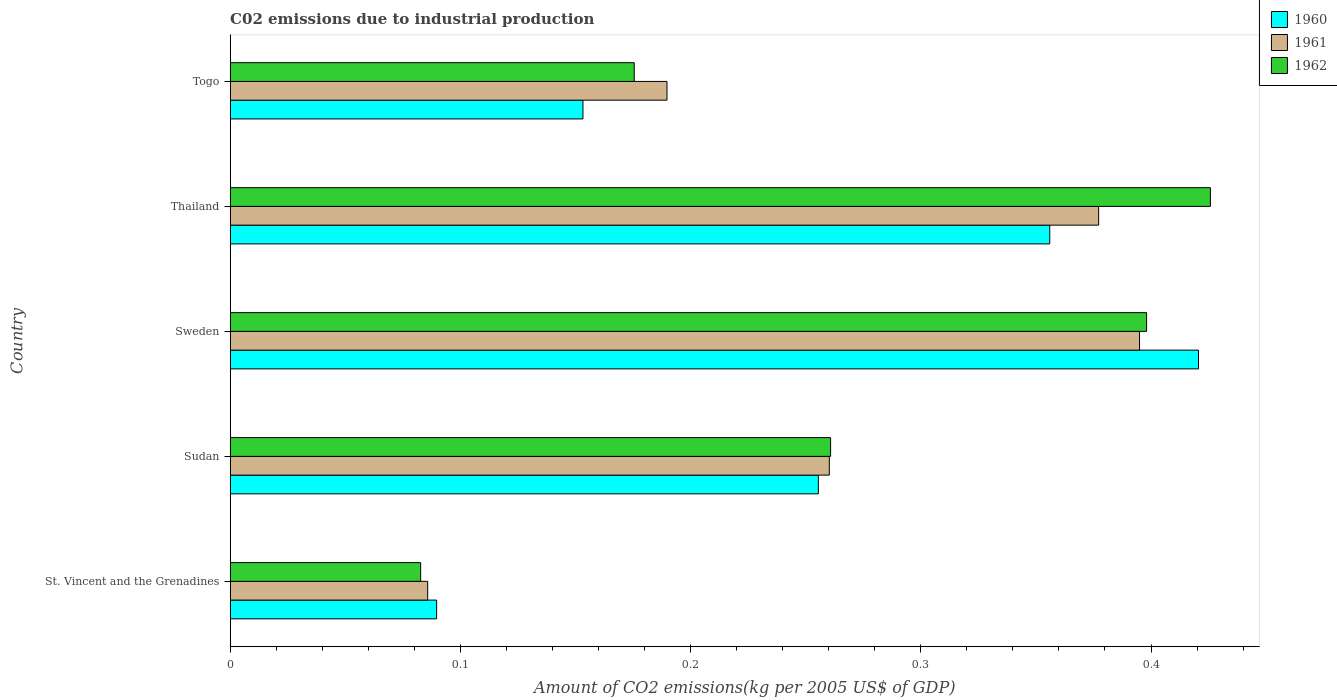Are the number of bars per tick equal to the number of legend labels?
Offer a very short reply. Yes. Are the number of bars on each tick of the Y-axis equal?
Give a very brief answer. Yes. How many bars are there on the 4th tick from the bottom?
Keep it short and to the point. 3. What is the label of the 4th group of bars from the top?
Offer a terse response. Sudan. What is the amount of CO2 emitted due to industrial production in 1961 in Sweden?
Your answer should be compact. 0.4. Across all countries, what is the maximum amount of CO2 emitted due to industrial production in 1962?
Your answer should be compact. 0.43. Across all countries, what is the minimum amount of CO2 emitted due to industrial production in 1962?
Your answer should be very brief. 0.08. In which country was the amount of CO2 emitted due to industrial production in 1961 maximum?
Keep it short and to the point. Sweden. In which country was the amount of CO2 emitted due to industrial production in 1962 minimum?
Provide a short and direct response. St. Vincent and the Grenadines. What is the total amount of CO2 emitted due to industrial production in 1962 in the graph?
Keep it short and to the point. 1.34. What is the difference between the amount of CO2 emitted due to industrial production in 1961 in Sweden and that in Togo?
Give a very brief answer. 0.21. What is the difference between the amount of CO2 emitted due to industrial production in 1961 in Togo and the amount of CO2 emitted due to industrial production in 1962 in Sweden?
Your response must be concise. -0.21. What is the average amount of CO2 emitted due to industrial production in 1960 per country?
Provide a succinct answer. 0.26. What is the difference between the amount of CO2 emitted due to industrial production in 1961 and amount of CO2 emitted due to industrial production in 1962 in Thailand?
Give a very brief answer. -0.05. What is the ratio of the amount of CO2 emitted due to industrial production in 1960 in St. Vincent and the Grenadines to that in Togo?
Your answer should be compact. 0.59. Is the difference between the amount of CO2 emitted due to industrial production in 1961 in St. Vincent and the Grenadines and Sudan greater than the difference between the amount of CO2 emitted due to industrial production in 1962 in St. Vincent and the Grenadines and Sudan?
Give a very brief answer. Yes. What is the difference between the highest and the second highest amount of CO2 emitted due to industrial production in 1961?
Your answer should be compact. 0.02. What is the difference between the highest and the lowest amount of CO2 emitted due to industrial production in 1960?
Give a very brief answer. 0.33. In how many countries, is the amount of CO2 emitted due to industrial production in 1960 greater than the average amount of CO2 emitted due to industrial production in 1960 taken over all countries?
Make the answer very short. 3. What does the 2nd bar from the bottom in Thailand represents?
Provide a succinct answer. 1961. Is it the case that in every country, the sum of the amount of CO2 emitted due to industrial production in 1960 and amount of CO2 emitted due to industrial production in 1961 is greater than the amount of CO2 emitted due to industrial production in 1962?
Your answer should be very brief. Yes. Are all the bars in the graph horizontal?
Keep it short and to the point. Yes. How many countries are there in the graph?
Keep it short and to the point. 5. Does the graph contain any zero values?
Ensure brevity in your answer.  No. How many legend labels are there?
Ensure brevity in your answer.  3. How are the legend labels stacked?
Give a very brief answer. Vertical. What is the title of the graph?
Keep it short and to the point. C02 emissions due to industrial production. What is the label or title of the X-axis?
Offer a terse response. Amount of CO2 emissions(kg per 2005 US$ of GDP). What is the Amount of CO2 emissions(kg per 2005 US$ of GDP) of 1960 in St. Vincent and the Grenadines?
Give a very brief answer. 0.09. What is the Amount of CO2 emissions(kg per 2005 US$ of GDP) in 1961 in St. Vincent and the Grenadines?
Provide a short and direct response. 0.09. What is the Amount of CO2 emissions(kg per 2005 US$ of GDP) in 1962 in St. Vincent and the Grenadines?
Your response must be concise. 0.08. What is the Amount of CO2 emissions(kg per 2005 US$ of GDP) in 1960 in Sudan?
Offer a terse response. 0.26. What is the Amount of CO2 emissions(kg per 2005 US$ of GDP) in 1961 in Sudan?
Offer a very short reply. 0.26. What is the Amount of CO2 emissions(kg per 2005 US$ of GDP) in 1962 in Sudan?
Your response must be concise. 0.26. What is the Amount of CO2 emissions(kg per 2005 US$ of GDP) of 1960 in Sweden?
Your response must be concise. 0.42. What is the Amount of CO2 emissions(kg per 2005 US$ of GDP) of 1961 in Sweden?
Your answer should be compact. 0.4. What is the Amount of CO2 emissions(kg per 2005 US$ of GDP) of 1962 in Sweden?
Your answer should be compact. 0.4. What is the Amount of CO2 emissions(kg per 2005 US$ of GDP) of 1960 in Thailand?
Make the answer very short. 0.36. What is the Amount of CO2 emissions(kg per 2005 US$ of GDP) of 1961 in Thailand?
Your answer should be compact. 0.38. What is the Amount of CO2 emissions(kg per 2005 US$ of GDP) of 1962 in Thailand?
Provide a short and direct response. 0.43. What is the Amount of CO2 emissions(kg per 2005 US$ of GDP) in 1960 in Togo?
Ensure brevity in your answer.  0.15. What is the Amount of CO2 emissions(kg per 2005 US$ of GDP) of 1961 in Togo?
Offer a very short reply. 0.19. What is the Amount of CO2 emissions(kg per 2005 US$ of GDP) in 1962 in Togo?
Make the answer very short. 0.18. Across all countries, what is the maximum Amount of CO2 emissions(kg per 2005 US$ of GDP) in 1960?
Give a very brief answer. 0.42. Across all countries, what is the maximum Amount of CO2 emissions(kg per 2005 US$ of GDP) of 1961?
Ensure brevity in your answer.  0.4. Across all countries, what is the maximum Amount of CO2 emissions(kg per 2005 US$ of GDP) of 1962?
Your answer should be very brief. 0.43. Across all countries, what is the minimum Amount of CO2 emissions(kg per 2005 US$ of GDP) of 1960?
Provide a succinct answer. 0.09. Across all countries, what is the minimum Amount of CO2 emissions(kg per 2005 US$ of GDP) of 1961?
Provide a succinct answer. 0.09. Across all countries, what is the minimum Amount of CO2 emissions(kg per 2005 US$ of GDP) of 1962?
Offer a terse response. 0.08. What is the total Amount of CO2 emissions(kg per 2005 US$ of GDP) in 1960 in the graph?
Your response must be concise. 1.27. What is the total Amount of CO2 emissions(kg per 2005 US$ of GDP) in 1961 in the graph?
Make the answer very short. 1.31. What is the total Amount of CO2 emissions(kg per 2005 US$ of GDP) in 1962 in the graph?
Provide a short and direct response. 1.34. What is the difference between the Amount of CO2 emissions(kg per 2005 US$ of GDP) of 1960 in St. Vincent and the Grenadines and that in Sudan?
Your answer should be compact. -0.17. What is the difference between the Amount of CO2 emissions(kg per 2005 US$ of GDP) of 1961 in St. Vincent and the Grenadines and that in Sudan?
Make the answer very short. -0.17. What is the difference between the Amount of CO2 emissions(kg per 2005 US$ of GDP) of 1962 in St. Vincent and the Grenadines and that in Sudan?
Give a very brief answer. -0.18. What is the difference between the Amount of CO2 emissions(kg per 2005 US$ of GDP) in 1960 in St. Vincent and the Grenadines and that in Sweden?
Your answer should be compact. -0.33. What is the difference between the Amount of CO2 emissions(kg per 2005 US$ of GDP) of 1961 in St. Vincent and the Grenadines and that in Sweden?
Your answer should be very brief. -0.31. What is the difference between the Amount of CO2 emissions(kg per 2005 US$ of GDP) in 1962 in St. Vincent and the Grenadines and that in Sweden?
Your response must be concise. -0.32. What is the difference between the Amount of CO2 emissions(kg per 2005 US$ of GDP) in 1960 in St. Vincent and the Grenadines and that in Thailand?
Ensure brevity in your answer.  -0.27. What is the difference between the Amount of CO2 emissions(kg per 2005 US$ of GDP) of 1961 in St. Vincent and the Grenadines and that in Thailand?
Provide a succinct answer. -0.29. What is the difference between the Amount of CO2 emissions(kg per 2005 US$ of GDP) of 1962 in St. Vincent and the Grenadines and that in Thailand?
Provide a short and direct response. -0.34. What is the difference between the Amount of CO2 emissions(kg per 2005 US$ of GDP) in 1960 in St. Vincent and the Grenadines and that in Togo?
Make the answer very short. -0.06. What is the difference between the Amount of CO2 emissions(kg per 2005 US$ of GDP) in 1961 in St. Vincent and the Grenadines and that in Togo?
Give a very brief answer. -0.1. What is the difference between the Amount of CO2 emissions(kg per 2005 US$ of GDP) of 1962 in St. Vincent and the Grenadines and that in Togo?
Offer a terse response. -0.09. What is the difference between the Amount of CO2 emissions(kg per 2005 US$ of GDP) in 1960 in Sudan and that in Sweden?
Keep it short and to the point. -0.17. What is the difference between the Amount of CO2 emissions(kg per 2005 US$ of GDP) of 1961 in Sudan and that in Sweden?
Provide a short and direct response. -0.13. What is the difference between the Amount of CO2 emissions(kg per 2005 US$ of GDP) of 1962 in Sudan and that in Sweden?
Make the answer very short. -0.14. What is the difference between the Amount of CO2 emissions(kg per 2005 US$ of GDP) of 1960 in Sudan and that in Thailand?
Provide a succinct answer. -0.1. What is the difference between the Amount of CO2 emissions(kg per 2005 US$ of GDP) of 1961 in Sudan and that in Thailand?
Your response must be concise. -0.12. What is the difference between the Amount of CO2 emissions(kg per 2005 US$ of GDP) in 1962 in Sudan and that in Thailand?
Your answer should be compact. -0.17. What is the difference between the Amount of CO2 emissions(kg per 2005 US$ of GDP) in 1960 in Sudan and that in Togo?
Offer a terse response. 0.1. What is the difference between the Amount of CO2 emissions(kg per 2005 US$ of GDP) in 1961 in Sudan and that in Togo?
Offer a terse response. 0.07. What is the difference between the Amount of CO2 emissions(kg per 2005 US$ of GDP) of 1962 in Sudan and that in Togo?
Keep it short and to the point. 0.09. What is the difference between the Amount of CO2 emissions(kg per 2005 US$ of GDP) of 1960 in Sweden and that in Thailand?
Provide a short and direct response. 0.06. What is the difference between the Amount of CO2 emissions(kg per 2005 US$ of GDP) of 1961 in Sweden and that in Thailand?
Offer a terse response. 0.02. What is the difference between the Amount of CO2 emissions(kg per 2005 US$ of GDP) of 1962 in Sweden and that in Thailand?
Give a very brief answer. -0.03. What is the difference between the Amount of CO2 emissions(kg per 2005 US$ of GDP) in 1960 in Sweden and that in Togo?
Offer a very short reply. 0.27. What is the difference between the Amount of CO2 emissions(kg per 2005 US$ of GDP) in 1961 in Sweden and that in Togo?
Your answer should be very brief. 0.21. What is the difference between the Amount of CO2 emissions(kg per 2005 US$ of GDP) of 1962 in Sweden and that in Togo?
Offer a very short reply. 0.22. What is the difference between the Amount of CO2 emissions(kg per 2005 US$ of GDP) of 1960 in Thailand and that in Togo?
Provide a succinct answer. 0.2. What is the difference between the Amount of CO2 emissions(kg per 2005 US$ of GDP) in 1961 in Thailand and that in Togo?
Make the answer very short. 0.19. What is the difference between the Amount of CO2 emissions(kg per 2005 US$ of GDP) of 1962 in Thailand and that in Togo?
Offer a terse response. 0.25. What is the difference between the Amount of CO2 emissions(kg per 2005 US$ of GDP) in 1960 in St. Vincent and the Grenadines and the Amount of CO2 emissions(kg per 2005 US$ of GDP) in 1961 in Sudan?
Your response must be concise. -0.17. What is the difference between the Amount of CO2 emissions(kg per 2005 US$ of GDP) of 1960 in St. Vincent and the Grenadines and the Amount of CO2 emissions(kg per 2005 US$ of GDP) of 1962 in Sudan?
Your answer should be compact. -0.17. What is the difference between the Amount of CO2 emissions(kg per 2005 US$ of GDP) of 1961 in St. Vincent and the Grenadines and the Amount of CO2 emissions(kg per 2005 US$ of GDP) of 1962 in Sudan?
Provide a short and direct response. -0.17. What is the difference between the Amount of CO2 emissions(kg per 2005 US$ of GDP) of 1960 in St. Vincent and the Grenadines and the Amount of CO2 emissions(kg per 2005 US$ of GDP) of 1961 in Sweden?
Your answer should be compact. -0.31. What is the difference between the Amount of CO2 emissions(kg per 2005 US$ of GDP) in 1960 in St. Vincent and the Grenadines and the Amount of CO2 emissions(kg per 2005 US$ of GDP) in 1962 in Sweden?
Ensure brevity in your answer.  -0.31. What is the difference between the Amount of CO2 emissions(kg per 2005 US$ of GDP) in 1961 in St. Vincent and the Grenadines and the Amount of CO2 emissions(kg per 2005 US$ of GDP) in 1962 in Sweden?
Keep it short and to the point. -0.31. What is the difference between the Amount of CO2 emissions(kg per 2005 US$ of GDP) in 1960 in St. Vincent and the Grenadines and the Amount of CO2 emissions(kg per 2005 US$ of GDP) in 1961 in Thailand?
Provide a succinct answer. -0.29. What is the difference between the Amount of CO2 emissions(kg per 2005 US$ of GDP) of 1960 in St. Vincent and the Grenadines and the Amount of CO2 emissions(kg per 2005 US$ of GDP) of 1962 in Thailand?
Your answer should be compact. -0.34. What is the difference between the Amount of CO2 emissions(kg per 2005 US$ of GDP) in 1961 in St. Vincent and the Grenadines and the Amount of CO2 emissions(kg per 2005 US$ of GDP) in 1962 in Thailand?
Your answer should be very brief. -0.34. What is the difference between the Amount of CO2 emissions(kg per 2005 US$ of GDP) in 1960 in St. Vincent and the Grenadines and the Amount of CO2 emissions(kg per 2005 US$ of GDP) in 1961 in Togo?
Ensure brevity in your answer.  -0.1. What is the difference between the Amount of CO2 emissions(kg per 2005 US$ of GDP) of 1960 in St. Vincent and the Grenadines and the Amount of CO2 emissions(kg per 2005 US$ of GDP) of 1962 in Togo?
Provide a succinct answer. -0.09. What is the difference between the Amount of CO2 emissions(kg per 2005 US$ of GDP) of 1961 in St. Vincent and the Grenadines and the Amount of CO2 emissions(kg per 2005 US$ of GDP) of 1962 in Togo?
Your response must be concise. -0.09. What is the difference between the Amount of CO2 emissions(kg per 2005 US$ of GDP) of 1960 in Sudan and the Amount of CO2 emissions(kg per 2005 US$ of GDP) of 1961 in Sweden?
Make the answer very short. -0.14. What is the difference between the Amount of CO2 emissions(kg per 2005 US$ of GDP) of 1960 in Sudan and the Amount of CO2 emissions(kg per 2005 US$ of GDP) of 1962 in Sweden?
Make the answer very short. -0.14. What is the difference between the Amount of CO2 emissions(kg per 2005 US$ of GDP) of 1961 in Sudan and the Amount of CO2 emissions(kg per 2005 US$ of GDP) of 1962 in Sweden?
Provide a short and direct response. -0.14. What is the difference between the Amount of CO2 emissions(kg per 2005 US$ of GDP) of 1960 in Sudan and the Amount of CO2 emissions(kg per 2005 US$ of GDP) of 1961 in Thailand?
Provide a short and direct response. -0.12. What is the difference between the Amount of CO2 emissions(kg per 2005 US$ of GDP) of 1960 in Sudan and the Amount of CO2 emissions(kg per 2005 US$ of GDP) of 1962 in Thailand?
Provide a succinct answer. -0.17. What is the difference between the Amount of CO2 emissions(kg per 2005 US$ of GDP) in 1961 in Sudan and the Amount of CO2 emissions(kg per 2005 US$ of GDP) in 1962 in Thailand?
Offer a very short reply. -0.17. What is the difference between the Amount of CO2 emissions(kg per 2005 US$ of GDP) in 1960 in Sudan and the Amount of CO2 emissions(kg per 2005 US$ of GDP) in 1961 in Togo?
Your answer should be compact. 0.07. What is the difference between the Amount of CO2 emissions(kg per 2005 US$ of GDP) of 1961 in Sudan and the Amount of CO2 emissions(kg per 2005 US$ of GDP) of 1962 in Togo?
Your response must be concise. 0.08. What is the difference between the Amount of CO2 emissions(kg per 2005 US$ of GDP) in 1960 in Sweden and the Amount of CO2 emissions(kg per 2005 US$ of GDP) in 1961 in Thailand?
Make the answer very short. 0.04. What is the difference between the Amount of CO2 emissions(kg per 2005 US$ of GDP) in 1960 in Sweden and the Amount of CO2 emissions(kg per 2005 US$ of GDP) in 1962 in Thailand?
Your response must be concise. -0.01. What is the difference between the Amount of CO2 emissions(kg per 2005 US$ of GDP) of 1961 in Sweden and the Amount of CO2 emissions(kg per 2005 US$ of GDP) of 1962 in Thailand?
Give a very brief answer. -0.03. What is the difference between the Amount of CO2 emissions(kg per 2005 US$ of GDP) of 1960 in Sweden and the Amount of CO2 emissions(kg per 2005 US$ of GDP) of 1961 in Togo?
Give a very brief answer. 0.23. What is the difference between the Amount of CO2 emissions(kg per 2005 US$ of GDP) in 1960 in Sweden and the Amount of CO2 emissions(kg per 2005 US$ of GDP) in 1962 in Togo?
Your answer should be very brief. 0.25. What is the difference between the Amount of CO2 emissions(kg per 2005 US$ of GDP) in 1961 in Sweden and the Amount of CO2 emissions(kg per 2005 US$ of GDP) in 1962 in Togo?
Your answer should be very brief. 0.22. What is the difference between the Amount of CO2 emissions(kg per 2005 US$ of GDP) in 1960 in Thailand and the Amount of CO2 emissions(kg per 2005 US$ of GDP) in 1961 in Togo?
Ensure brevity in your answer.  0.17. What is the difference between the Amount of CO2 emissions(kg per 2005 US$ of GDP) in 1960 in Thailand and the Amount of CO2 emissions(kg per 2005 US$ of GDP) in 1962 in Togo?
Provide a succinct answer. 0.18. What is the difference between the Amount of CO2 emissions(kg per 2005 US$ of GDP) in 1961 in Thailand and the Amount of CO2 emissions(kg per 2005 US$ of GDP) in 1962 in Togo?
Keep it short and to the point. 0.2. What is the average Amount of CO2 emissions(kg per 2005 US$ of GDP) of 1960 per country?
Make the answer very short. 0.26. What is the average Amount of CO2 emissions(kg per 2005 US$ of GDP) of 1961 per country?
Provide a short and direct response. 0.26. What is the average Amount of CO2 emissions(kg per 2005 US$ of GDP) in 1962 per country?
Provide a succinct answer. 0.27. What is the difference between the Amount of CO2 emissions(kg per 2005 US$ of GDP) in 1960 and Amount of CO2 emissions(kg per 2005 US$ of GDP) in 1961 in St. Vincent and the Grenadines?
Give a very brief answer. 0. What is the difference between the Amount of CO2 emissions(kg per 2005 US$ of GDP) of 1960 and Amount of CO2 emissions(kg per 2005 US$ of GDP) of 1962 in St. Vincent and the Grenadines?
Keep it short and to the point. 0.01. What is the difference between the Amount of CO2 emissions(kg per 2005 US$ of GDP) of 1961 and Amount of CO2 emissions(kg per 2005 US$ of GDP) of 1962 in St. Vincent and the Grenadines?
Offer a terse response. 0. What is the difference between the Amount of CO2 emissions(kg per 2005 US$ of GDP) of 1960 and Amount of CO2 emissions(kg per 2005 US$ of GDP) of 1961 in Sudan?
Offer a terse response. -0. What is the difference between the Amount of CO2 emissions(kg per 2005 US$ of GDP) in 1960 and Amount of CO2 emissions(kg per 2005 US$ of GDP) in 1962 in Sudan?
Your answer should be very brief. -0.01. What is the difference between the Amount of CO2 emissions(kg per 2005 US$ of GDP) in 1961 and Amount of CO2 emissions(kg per 2005 US$ of GDP) in 1962 in Sudan?
Keep it short and to the point. -0. What is the difference between the Amount of CO2 emissions(kg per 2005 US$ of GDP) in 1960 and Amount of CO2 emissions(kg per 2005 US$ of GDP) in 1961 in Sweden?
Provide a succinct answer. 0.03. What is the difference between the Amount of CO2 emissions(kg per 2005 US$ of GDP) in 1960 and Amount of CO2 emissions(kg per 2005 US$ of GDP) in 1962 in Sweden?
Keep it short and to the point. 0.02. What is the difference between the Amount of CO2 emissions(kg per 2005 US$ of GDP) of 1961 and Amount of CO2 emissions(kg per 2005 US$ of GDP) of 1962 in Sweden?
Your answer should be compact. -0. What is the difference between the Amount of CO2 emissions(kg per 2005 US$ of GDP) of 1960 and Amount of CO2 emissions(kg per 2005 US$ of GDP) of 1961 in Thailand?
Keep it short and to the point. -0.02. What is the difference between the Amount of CO2 emissions(kg per 2005 US$ of GDP) in 1960 and Amount of CO2 emissions(kg per 2005 US$ of GDP) in 1962 in Thailand?
Make the answer very short. -0.07. What is the difference between the Amount of CO2 emissions(kg per 2005 US$ of GDP) of 1961 and Amount of CO2 emissions(kg per 2005 US$ of GDP) of 1962 in Thailand?
Your answer should be very brief. -0.05. What is the difference between the Amount of CO2 emissions(kg per 2005 US$ of GDP) of 1960 and Amount of CO2 emissions(kg per 2005 US$ of GDP) of 1961 in Togo?
Make the answer very short. -0.04. What is the difference between the Amount of CO2 emissions(kg per 2005 US$ of GDP) of 1960 and Amount of CO2 emissions(kg per 2005 US$ of GDP) of 1962 in Togo?
Offer a terse response. -0.02. What is the difference between the Amount of CO2 emissions(kg per 2005 US$ of GDP) in 1961 and Amount of CO2 emissions(kg per 2005 US$ of GDP) in 1962 in Togo?
Your answer should be very brief. 0.01. What is the ratio of the Amount of CO2 emissions(kg per 2005 US$ of GDP) in 1960 in St. Vincent and the Grenadines to that in Sudan?
Offer a very short reply. 0.35. What is the ratio of the Amount of CO2 emissions(kg per 2005 US$ of GDP) of 1961 in St. Vincent and the Grenadines to that in Sudan?
Ensure brevity in your answer.  0.33. What is the ratio of the Amount of CO2 emissions(kg per 2005 US$ of GDP) of 1962 in St. Vincent and the Grenadines to that in Sudan?
Provide a short and direct response. 0.32. What is the ratio of the Amount of CO2 emissions(kg per 2005 US$ of GDP) of 1960 in St. Vincent and the Grenadines to that in Sweden?
Your response must be concise. 0.21. What is the ratio of the Amount of CO2 emissions(kg per 2005 US$ of GDP) of 1961 in St. Vincent and the Grenadines to that in Sweden?
Offer a terse response. 0.22. What is the ratio of the Amount of CO2 emissions(kg per 2005 US$ of GDP) of 1962 in St. Vincent and the Grenadines to that in Sweden?
Your answer should be compact. 0.21. What is the ratio of the Amount of CO2 emissions(kg per 2005 US$ of GDP) of 1960 in St. Vincent and the Grenadines to that in Thailand?
Offer a terse response. 0.25. What is the ratio of the Amount of CO2 emissions(kg per 2005 US$ of GDP) in 1961 in St. Vincent and the Grenadines to that in Thailand?
Give a very brief answer. 0.23. What is the ratio of the Amount of CO2 emissions(kg per 2005 US$ of GDP) of 1962 in St. Vincent and the Grenadines to that in Thailand?
Make the answer very short. 0.19. What is the ratio of the Amount of CO2 emissions(kg per 2005 US$ of GDP) of 1960 in St. Vincent and the Grenadines to that in Togo?
Your response must be concise. 0.59. What is the ratio of the Amount of CO2 emissions(kg per 2005 US$ of GDP) of 1961 in St. Vincent and the Grenadines to that in Togo?
Provide a short and direct response. 0.45. What is the ratio of the Amount of CO2 emissions(kg per 2005 US$ of GDP) of 1962 in St. Vincent and the Grenadines to that in Togo?
Give a very brief answer. 0.47. What is the ratio of the Amount of CO2 emissions(kg per 2005 US$ of GDP) in 1960 in Sudan to that in Sweden?
Offer a terse response. 0.61. What is the ratio of the Amount of CO2 emissions(kg per 2005 US$ of GDP) in 1961 in Sudan to that in Sweden?
Offer a terse response. 0.66. What is the ratio of the Amount of CO2 emissions(kg per 2005 US$ of GDP) in 1962 in Sudan to that in Sweden?
Offer a terse response. 0.66. What is the ratio of the Amount of CO2 emissions(kg per 2005 US$ of GDP) of 1960 in Sudan to that in Thailand?
Give a very brief answer. 0.72. What is the ratio of the Amount of CO2 emissions(kg per 2005 US$ of GDP) of 1961 in Sudan to that in Thailand?
Offer a very short reply. 0.69. What is the ratio of the Amount of CO2 emissions(kg per 2005 US$ of GDP) of 1962 in Sudan to that in Thailand?
Offer a terse response. 0.61. What is the ratio of the Amount of CO2 emissions(kg per 2005 US$ of GDP) in 1960 in Sudan to that in Togo?
Your answer should be compact. 1.67. What is the ratio of the Amount of CO2 emissions(kg per 2005 US$ of GDP) of 1961 in Sudan to that in Togo?
Offer a terse response. 1.37. What is the ratio of the Amount of CO2 emissions(kg per 2005 US$ of GDP) of 1962 in Sudan to that in Togo?
Ensure brevity in your answer.  1.49. What is the ratio of the Amount of CO2 emissions(kg per 2005 US$ of GDP) in 1960 in Sweden to that in Thailand?
Offer a very short reply. 1.18. What is the ratio of the Amount of CO2 emissions(kg per 2005 US$ of GDP) in 1961 in Sweden to that in Thailand?
Your answer should be very brief. 1.05. What is the ratio of the Amount of CO2 emissions(kg per 2005 US$ of GDP) of 1962 in Sweden to that in Thailand?
Offer a very short reply. 0.93. What is the ratio of the Amount of CO2 emissions(kg per 2005 US$ of GDP) in 1960 in Sweden to that in Togo?
Your response must be concise. 2.74. What is the ratio of the Amount of CO2 emissions(kg per 2005 US$ of GDP) in 1961 in Sweden to that in Togo?
Offer a terse response. 2.08. What is the ratio of the Amount of CO2 emissions(kg per 2005 US$ of GDP) of 1962 in Sweden to that in Togo?
Provide a succinct answer. 2.27. What is the ratio of the Amount of CO2 emissions(kg per 2005 US$ of GDP) in 1960 in Thailand to that in Togo?
Make the answer very short. 2.32. What is the ratio of the Amount of CO2 emissions(kg per 2005 US$ of GDP) of 1961 in Thailand to that in Togo?
Provide a succinct answer. 1.99. What is the ratio of the Amount of CO2 emissions(kg per 2005 US$ of GDP) in 1962 in Thailand to that in Togo?
Ensure brevity in your answer.  2.43. What is the difference between the highest and the second highest Amount of CO2 emissions(kg per 2005 US$ of GDP) in 1960?
Provide a short and direct response. 0.06. What is the difference between the highest and the second highest Amount of CO2 emissions(kg per 2005 US$ of GDP) of 1961?
Keep it short and to the point. 0.02. What is the difference between the highest and the second highest Amount of CO2 emissions(kg per 2005 US$ of GDP) in 1962?
Give a very brief answer. 0.03. What is the difference between the highest and the lowest Amount of CO2 emissions(kg per 2005 US$ of GDP) in 1960?
Offer a terse response. 0.33. What is the difference between the highest and the lowest Amount of CO2 emissions(kg per 2005 US$ of GDP) in 1961?
Keep it short and to the point. 0.31. What is the difference between the highest and the lowest Amount of CO2 emissions(kg per 2005 US$ of GDP) of 1962?
Your answer should be very brief. 0.34. 